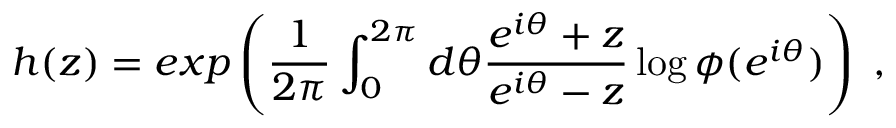Convert formula to latex. <formula><loc_0><loc_0><loc_500><loc_500>h ( z ) = e x p \left ( { \frac { 1 } { 2 \pi } } \int _ { 0 } ^ { 2 \pi } d \theta { \frac { e ^ { i \theta } + z } { e ^ { i \theta } - z } } \log \phi ( e ^ { i \theta } ) \right ) \, ,</formula> 